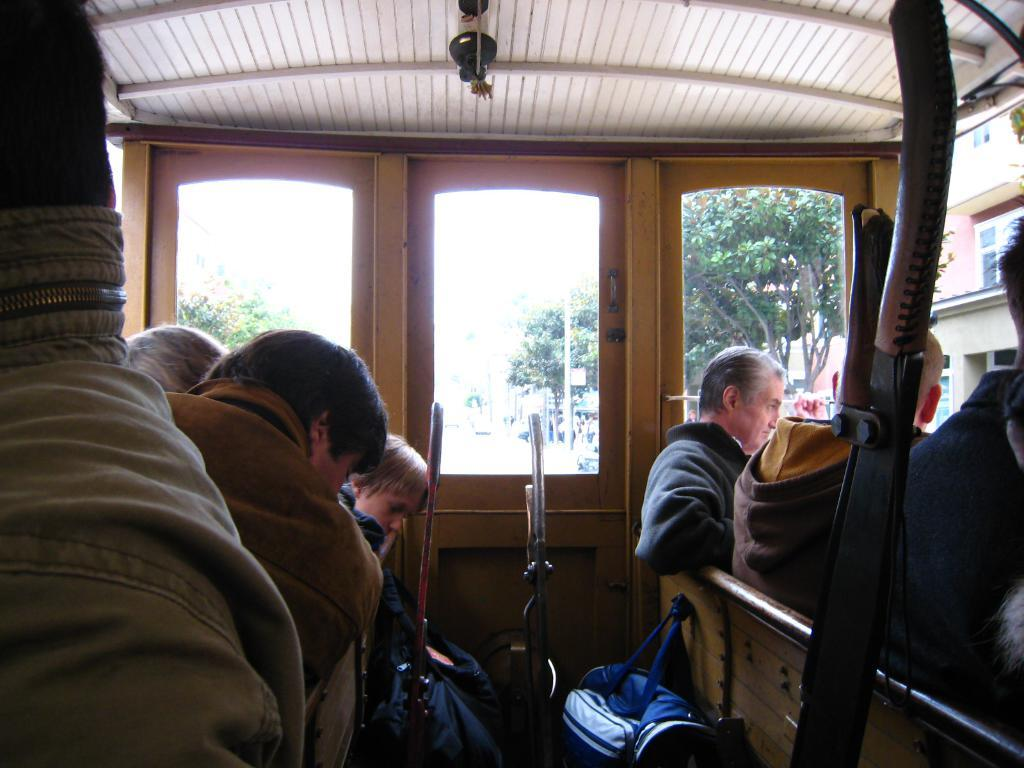What are the people in the image sitting on? There are people sitting on a wooden bench in the image. What object can be seen near the people sitting on the bench? There is a travel bag visible in the image. What type of structure is present in the image? There is a roof ceiling in the image. How many pigs are sitting on the bench with the people in the image? There are no pigs present in the image; only people are sitting on the bench. What type of hook can be seen hanging from the roof ceiling in the image? There is no hook visible in the image; only a roof ceiling is mentioned. 